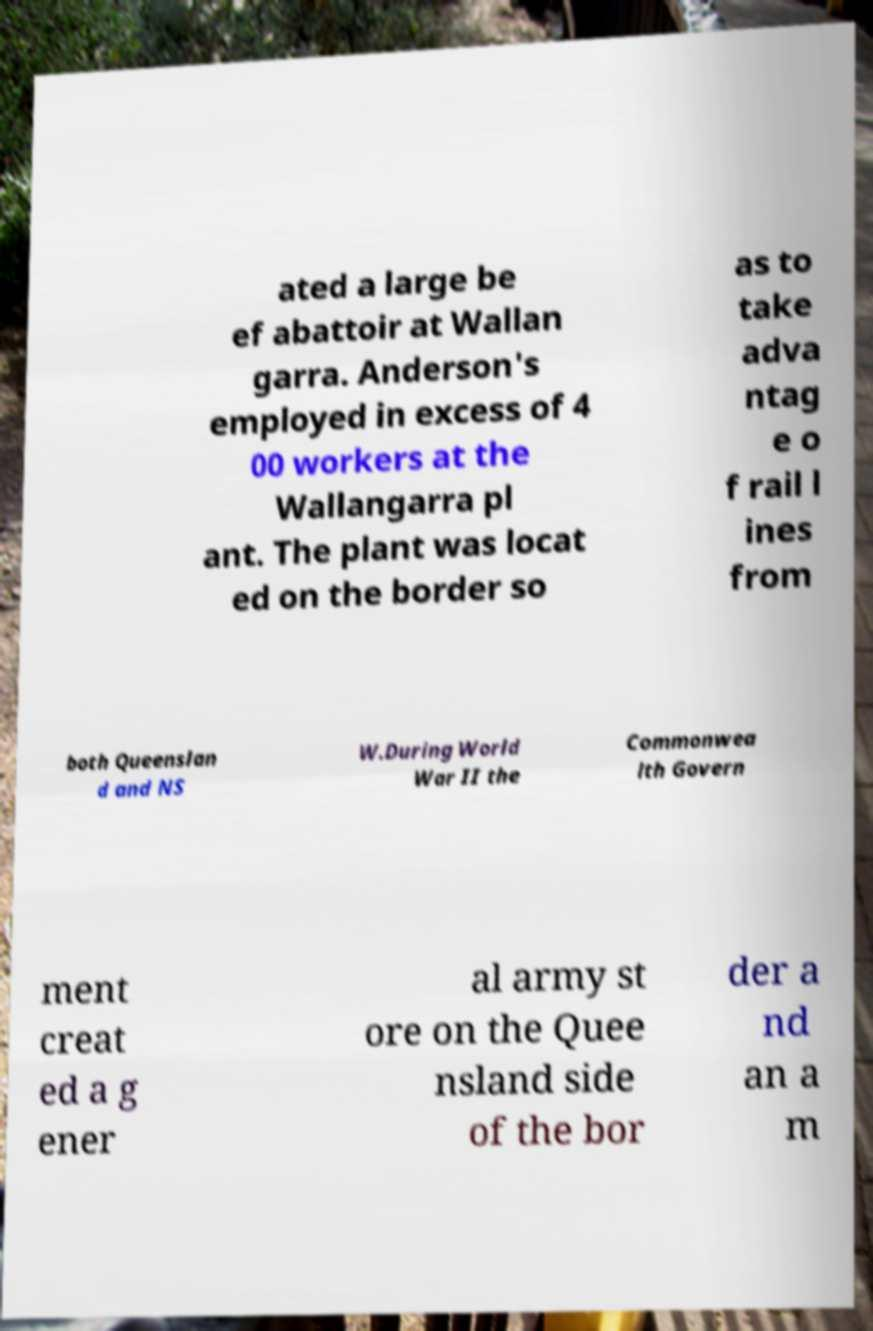I need the written content from this picture converted into text. Can you do that? ated a large be ef abattoir at Wallan garra. Anderson's employed in excess of 4 00 workers at the Wallangarra pl ant. The plant was locat ed on the border so as to take adva ntag e o f rail l ines from both Queenslan d and NS W.During World War II the Commonwea lth Govern ment creat ed a g ener al army st ore on the Quee nsland side of the bor der a nd an a m 